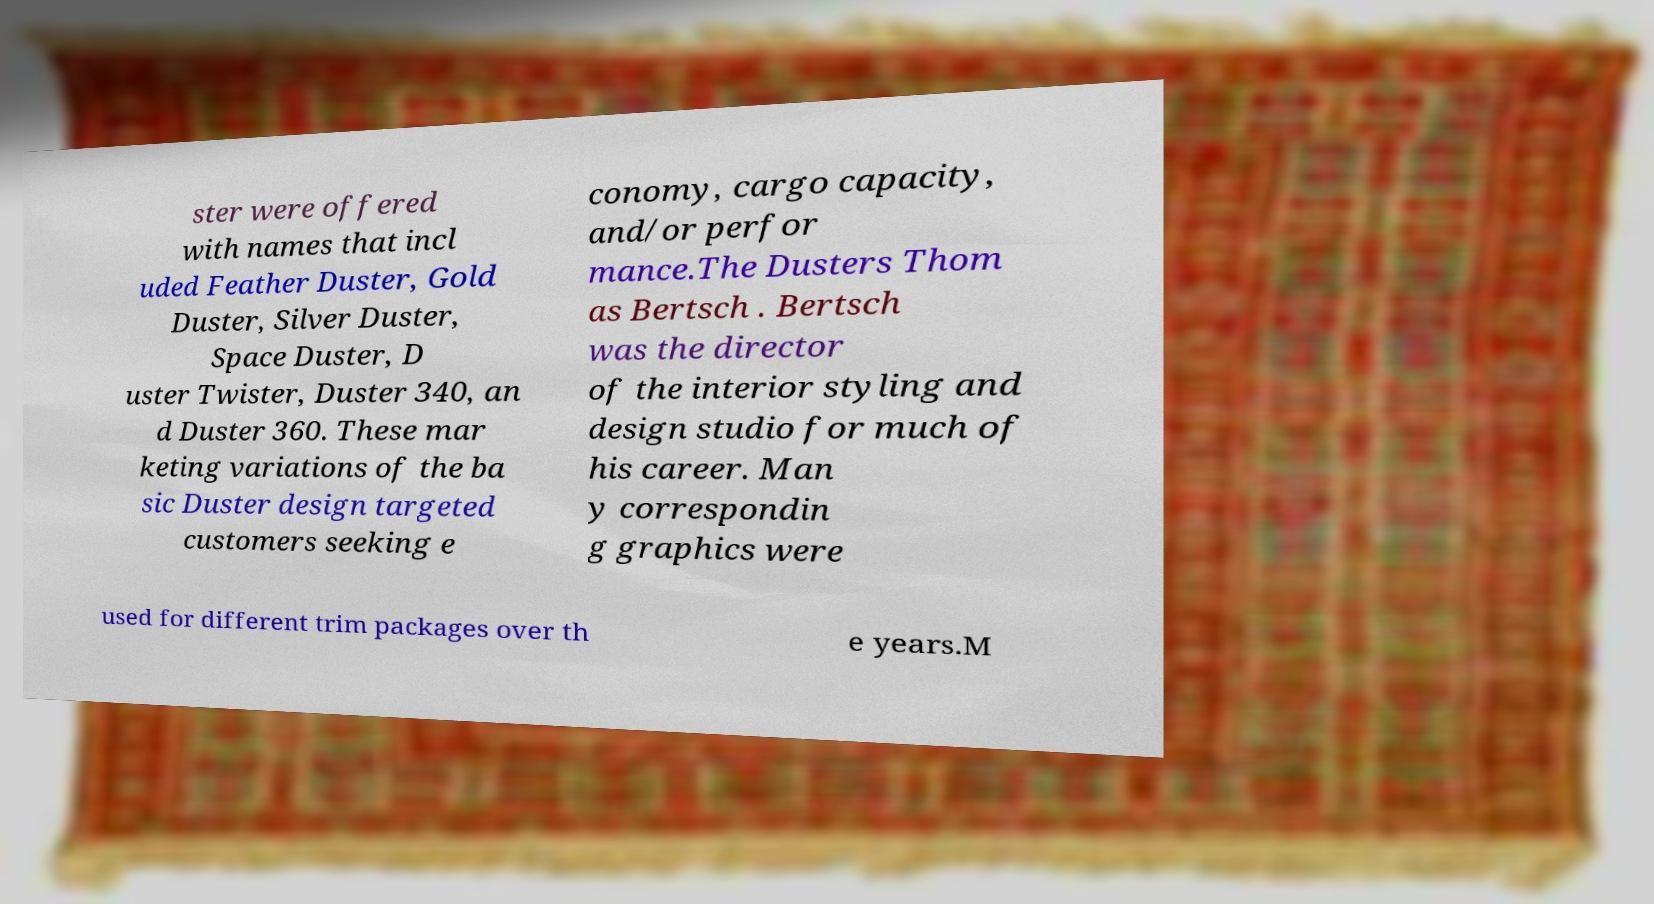What messages or text are displayed in this image? I need them in a readable, typed format. ster were offered with names that incl uded Feather Duster, Gold Duster, Silver Duster, Space Duster, D uster Twister, Duster 340, an d Duster 360. These mar keting variations of the ba sic Duster design targeted customers seeking e conomy, cargo capacity, and/or perfor mance.The Dusters Thom as Bertsch . Bertsch was the director of the interior styling and design studio for much of his career. Man y correspondin g graphics were used for different trim packages over th e years.M 